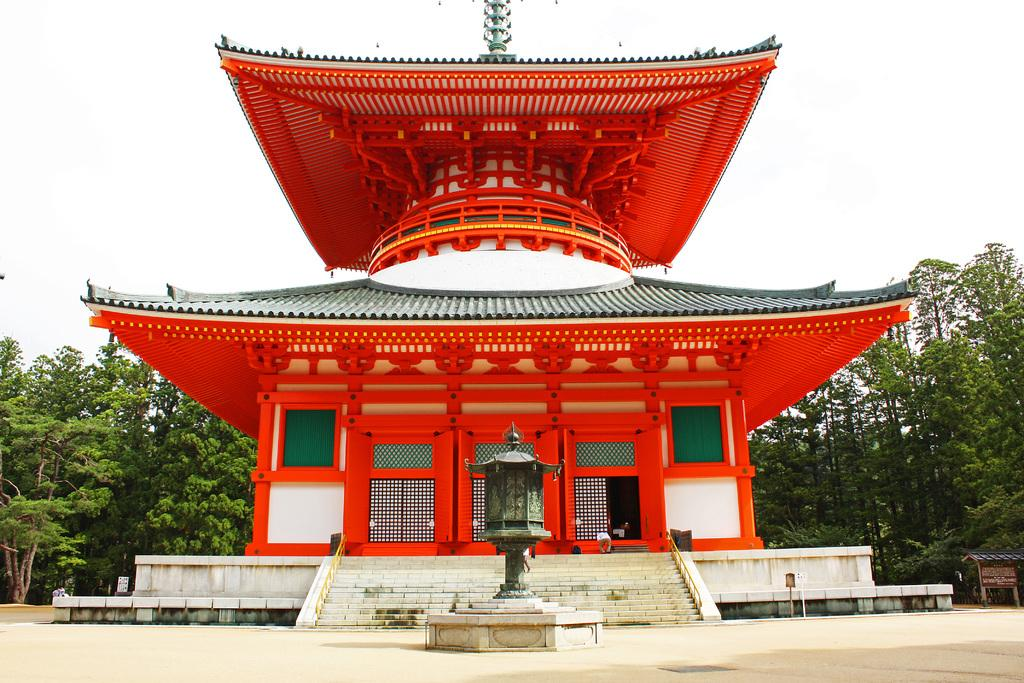What type of structure is present in the image? There is a building in the image. What other natural elements can be seen in the image? There are trees in the image. What part of the natural environment is visible in the image? The sky is visible in the image. How many fowl are perched on the building in the image? There are no fowl present in the image. What is the role of the judge in the image? There is no judge present in the image. 